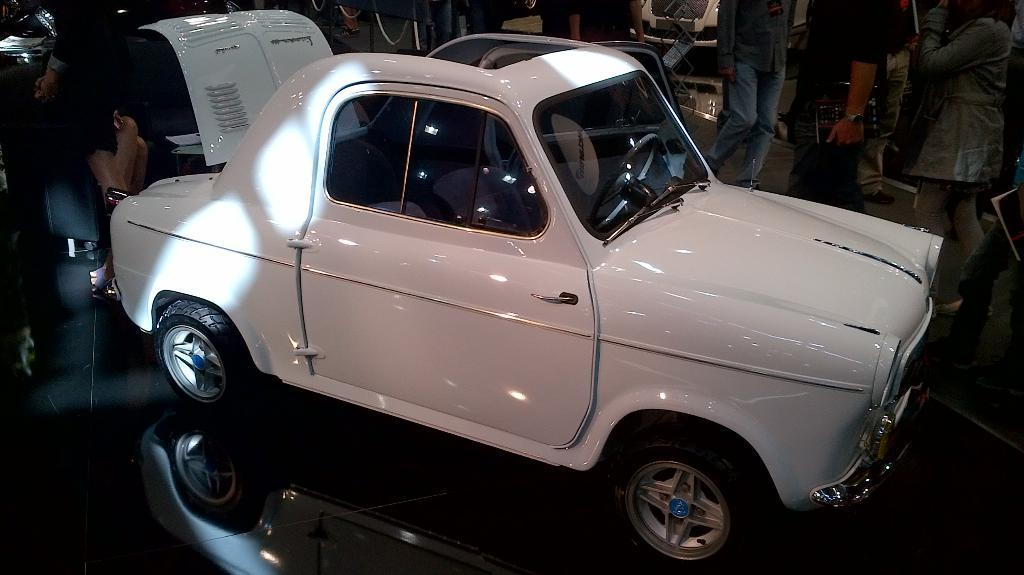What is the main subject in the center of the image? There is a car in the center of the image. What can be seen in the background of the image? There are many people in the background of the image. What type of leather is used to make the car's seats in the image? The image does not provide information about the type of leather used for the car's seats. Can you hear anyone crying in the image? The image is silent, and there is no indication of anyone crying. 